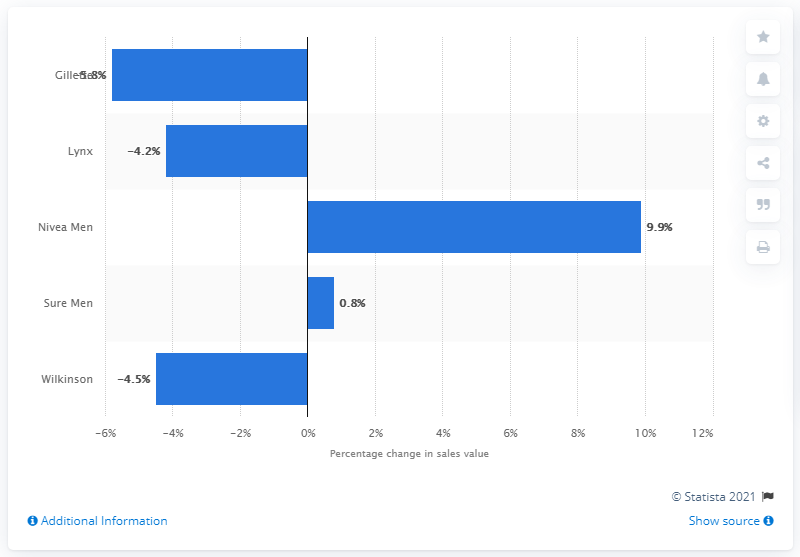Draw attention to some important aspects in this diagram. The brand with the highest growth in sales value over the specified time period was Nivea Men. 